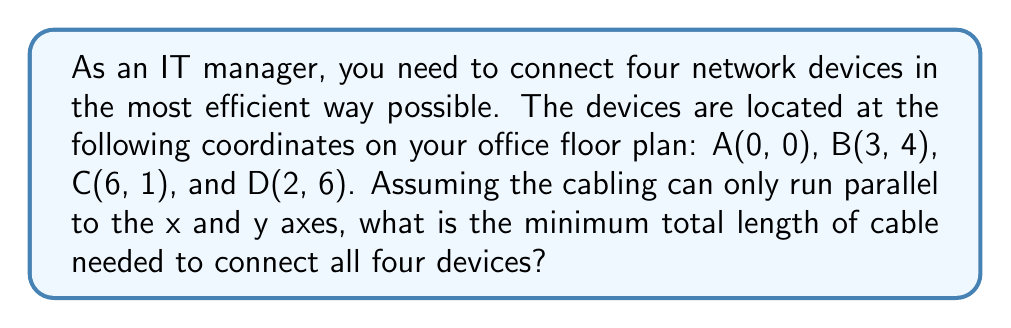Teach me how to tackle this problem. To solve this problem, we need to find the shortest path that connects all four points, known as the minimum spanning tree. Since the cabling can only run parallel to the axes, we'll use the Manhattan distance (also known as L1 distance or taxicab geometry) instead of Euclidean distance.

Step 1: Calculate all possible distances between the points.
$$ d_{AB} = |3-0| + |4-0| = 7 $$
$$ d_{AC} = |6-0| + |1-0| = 7 $$
$$ d_{AD} = |2-0| + |6-0| = 8 $$
$$ d_{BC} = |6-3| + |1-4| = 6 $$
$$ d_{BD} = |2-3| + |6-4| = 3 $$
$$ d_{CD} = |2-6| + |6-1| = 9 $$

Step 2: Use Kruskal's algorithm to find the minimum spanning tree.
1. Sort the edges by length: BD (3), BC (6), AB (7), AC (7), AD (8), CD (9)
2. Add BD to the tree
3. Add BC to the tree
4. Add AB to the tree (AC would create a cycle)

Step 3: Calculate the total length of the minimum spanning tree.
$$ \text{Total length} = d_{BD} + d_{BC} + d_{AB} = 3 + 6 + 7 = 16 $$

[asy]
unitsize(20);
dot((0,0)); dot((3,4)); dot((6,1)); dot((2,6));
label("A(0,0)", (0,0), SW);
label("B(3,4)", (3,4), NE);
label("C(6,1)", (6,1), SE);
label("D(2,6)", (2,6), NW);
draw((0,0)--(3,0)--(3,4), blue);
draw((3,4)--(3,1)--(6,1), blue);
draw((3,4)--(2,4)--(2,6), blue);
[/asy]

Therefore, the minimum total length of cable needed to connect all four devices is 16 units.
Answer: The minimum total length of cable needed to connect all four devices is 16 units. 